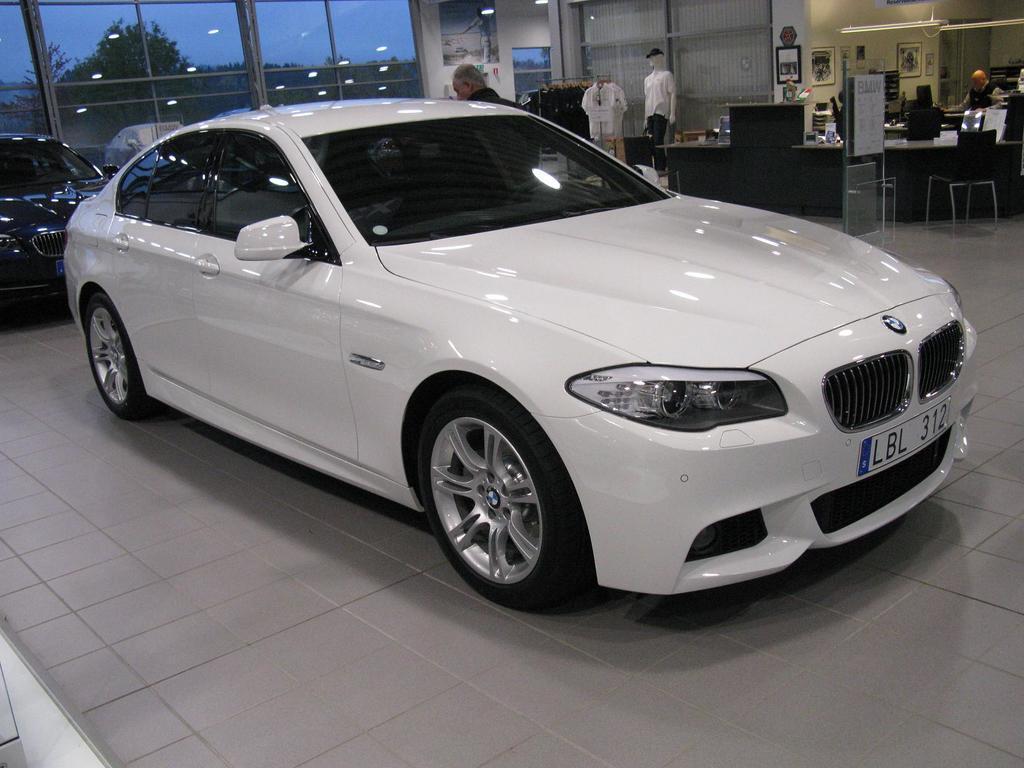How would you summarize this image in a sentence or two? In this image there are cars parked on the floor. Behind the cars there are glass walls. Outside the walls there are trees and the sky. In the top right there are tables. There are a few people near to the tables. Behind them there is a wall. There are picture frames on the wall. There is a mannequin in the image. Beside the mannequin there are shirts hanging to the rods. There are lights to the ceiling. 